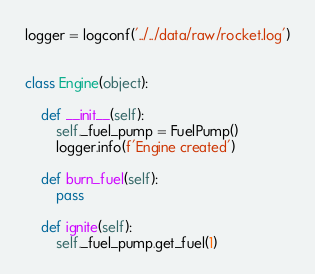<code> <loc_0><loc_0><loc_500><loc_500><_Python_>
logger = logconf('../../data/raw/rocket.log')


class Engine(object):

    def __init__(self):
        self._fuel_pump = FuelPump()
        logger.info(f'Engine created')

    def burn_fuel(self):
        pass

    def ignite(self):
        self._fuel_pump.get_fuel(1)

</code> 